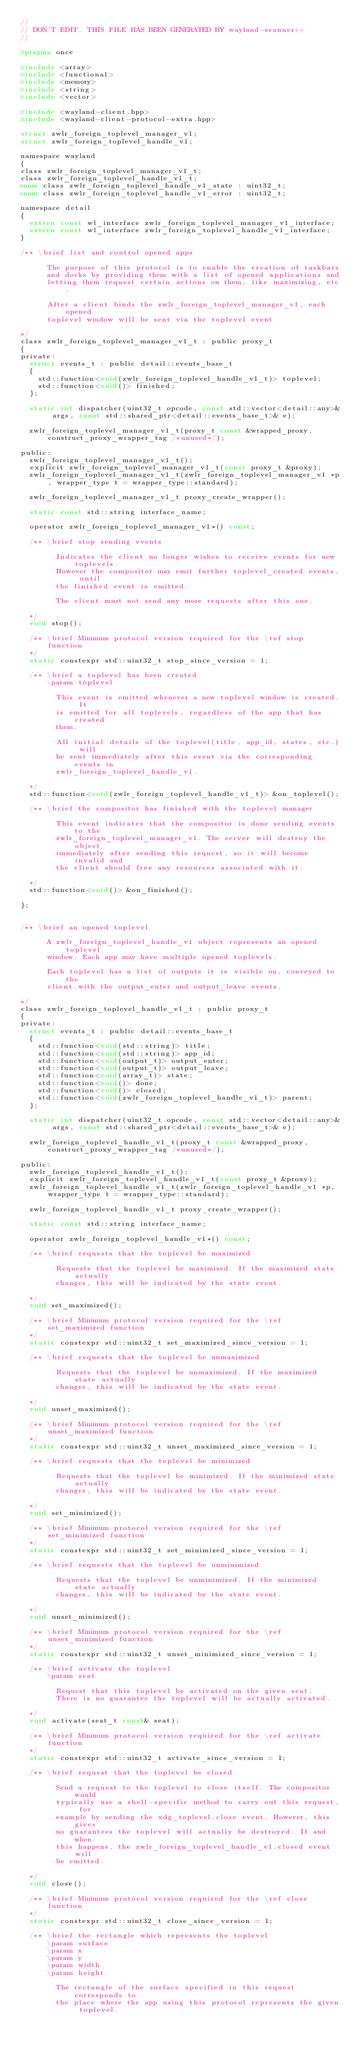<code> <loc_0><loc_0><loc_500><loc_500><_C_>//
// DON'T EDIT. THIS FILE HAS BEEN GENERATED BY wayland-scanner++
//

#pragma once

#include <array>
#include <functional>
#include <memory>
#include <string>
#include <vector>

#include <wayland-client.hpp>
#include <wayland-client-protocol-extra.hpp>

struct zwlr_foreign_toplevel_manager_v1;
struct zwlr_foreign_toplevel_handle_v1;

namespace wayland
{
class zwlr_foreign_toplevel_manager_v1_t;
class zwlr_foreign_toplevel_handle_v1_t;
enum class zwlr_foreign_toplevel_handle_v1_state : uint32_t;
enum class zwlr_foreign_toplevel_handle_v1_error : uint32_t;

namespace detail
{
  extern const wl_interface zwlr_foreign_toplevel_manager_v1_interface;
  extern const wl_interface zwlr_foreign_toplevel_handle_v1_interface;
}

/** \brief list and control opened apps

      The purpose of this protocol is to enable the creation of taskbars
      and docks by providing them with a list of opened applications and
      letting them request certain actions on them, like maximizing, etc.

      After a client binds the zwlr_foreign_toplevel_manager_v1, each opened
      toplevel window will be sent via the toplevel event
    
*/
class zwlr_foreign_toplevel_manager_v1_t : public proxy_t
{
private:
  struct events_t : public detail::events_base_t
  {
    std::function<void(zwlr_foreign_toplevel_handle_v1_t)> toplevel;
    std::function<void()> finished;
  };

  static int dispatcher(uint32_t opcode, const std::vector<detail::any>& args, const std::shared_ptr<detail::events_base_t>& e);

  zwlr_foreign_toplevel_manager_v1_t(proxy_t const &wrapped_proxy, construct_proxy_wrapper_tag /*unused*/);

public:
  zwlr_foreign_toplevel_manager_v1_t();
  explicit zwlr_foreign_toplevel_manager_v1_t(const proxy_t &proxy);
  zwlr_foreign_toplevel_manager_v1_t(zwlr_foreign_toplevel_manager_v1 *p, wrapper_type t = wrapper_type::standard);

  zwlr_foreign_toplevel_manager_v1_t proxy_create_wrapper();

  static const std::string interface_name;

  operator zwlr_foreign_toplevel_manager_v1*() const;

  /** \brief stop sending events

        Indicates the client no longer wishes to receive events for new toplevels.
        However the compositor may emit further toplevel_created events, until
        the finished event is emitted.

        The client must not send any more requests after this one.
      
  */
  void stop();

  /** \brief Minimum protocol version required for the \ref stop function
  */
  static constexpr std::uint32_t stop_since_version = 1;

  /** \brief a toplevel has been created
      \param toplevel 

        This event is emitted whenever a new toplevel window is created. It
        is emitted for all toplevels, regardless of the app that has created
        them.

        All initial details of the toplevel(title, app_id, states, etc.) will
        be sent immediately after this event via the corresponding events in
        zwlr_foreign_toplevel_handle_v1.
      
  */
  std::function<void(zwlr_foreign_toplevel_handle_v1_t)> &on_toplevel();

  /** \brief the compositor has finished with the toplevel manager

        This event indicates that the compositor is done sending events to the
        zwlr_foreign_toplevel_manager_v1. The server will destroy the object
        immediately after sending this request, so it will become invalid and
        the client should free any resources associated with it.
      
  */
  std::function<void()> &on_finished();

};


/** \brief an opened toplevel

      A zwlr_foreign_toplevel_handle_v1 object represents an opened toplevel
      window. Each app may have multiple opened toplevels.

      Each toplevel has a list of outputs it is visible on, conveyed to the
      client with the output_enter and output_leave events.
    
*/
class zwlr_foreign_toplevel_handle_v1_t : public proxy_t
{
private:
  struct events_t : public detail::events_base_t
  {
    std::function<void(std::string)> title;
    std::function<void(std::string)> app_id;
    std::function<void(output_t)> output_enter;
    std::function<void(output_t)> output_leave;
    std::function<void(array_t)> state;
    std::function<void()> done;
    std::function<void()> closed;
    std::function<void(zwlr_foreign_toplevel_handle_v1_t)> parent;
  };

  static int dispatcher(uint32_t opcode, const std::vector<detail::any>& args, const std::shared_ptr<detail::events_base_t>& e);

  zwlr_foreign_toplevel_handle_v1_t(proxy_t const &wrapped_proxy, construct_proxy_wrapper_tag /*unused*/);

public:
  zwlr_foreign_toplevel_handle_v1_t();
  explicit zwlr_foreign_toplevel_handle_v1_t(const proxy_t &proxy);
  zwlr_foreign_toplevel_handle_v1_t(zwlr_foreign_toplevel_handle_v1 *p, wrapper_type t = wrapper_type::standard);

  zwlr_foreign_toplevel_handle_v1_t proxy_create_wrapper();

  static const std::string interface_name;

  operator zwlr_foreign_toplevel_handle_v1*() const;

  /** \brief requests that the toplevel be maximized

        Requests that the toplevel be maximized. If the maximized state actually
        changes, this will be indicated by the state event.
      
  */
  void set_maximized();

  /** \brief Minimum protocol version required for the \ref set_maximized function
  */
  static constexpr std::uint32_t set_maximized_since_version = 1;

  /** \brief requests that the toplevel be unmaximized

        Requests that the toplevel be unmaximized. If the maximized state actually
        changes, this will be indicated by the state event.
      
  */
  void unset_maximized();

  /** \brief Minimum protocol version required for the \ref unset_maximized function
  */
  static constexpr std::uint32_t unset_maximized_since_version = 1;

  /** \brief requests that the toplevel be minimized

        Requests that the toplevel be minimized. If the minimized state actually
        changes, this will be indicated by the state event.
      
  */
  void set_minimized();

  /** \brief Minimum protocol version required for the \ref set_minimized function
  */
  static constexpr std::uint32_t set_minimized_since_version = 1;

  /** \brief requests that the toplevel be unminimized

        Requests that the toplevel be unminimized. If the minimized state actually
        changes, this will be indicated by the state event.
      
  */
  void unset_minimized();

  /** \brief Minimum protocol version required for the \ref unset_minimized function
  */
  static constexpr std::uint32_t unset_minimized_since_version = 1;

  /** \brief activate the toplevel
      \param seat 

        Request that this toplevel be activated on the given seat.
        There is no guarantee the toplevel will be actually activated.
      
  */
  void activate(seat_t const& seat);

  /** \brief Minimum protocol version required for the \ref activate function
  */
  static constexpr std::uint32_t activate_since_version = 1;

  /** \brief request that the toplevel be closed

        Send a request to the toplevel to close itself. The compositor would
        typically use a shell-specific method to carry out this request, for
        example by sending the xdg_toplevel.close event. However, this gives
        no guarantees the toplevel will actually be destroyed. If and when
        this happens, the zwlr_foreign_toplevel_handle_v1.closed event will
        be emitted.
      
  */
  void close();

  /** \brief Minimum protocol version required for the \ref close function
  */
  static constexpr std::uint32_t close_since_version = 1;

  /** \brief the rectangle which represents the toplevel
      \param surface 
      \param x 
      \param y 
      \param width 
      \param height 

        The rectangle of the surface specified in this request corresponds to
        the place where the app using this protocol represents the given toplevel.</code> 